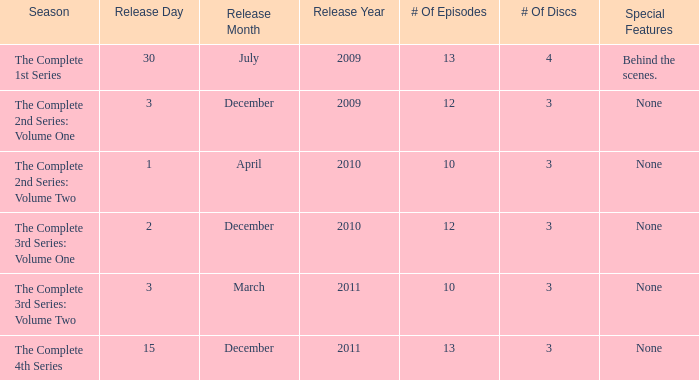What day was the complete 2nd series: volume one released? 3 December 2009. 